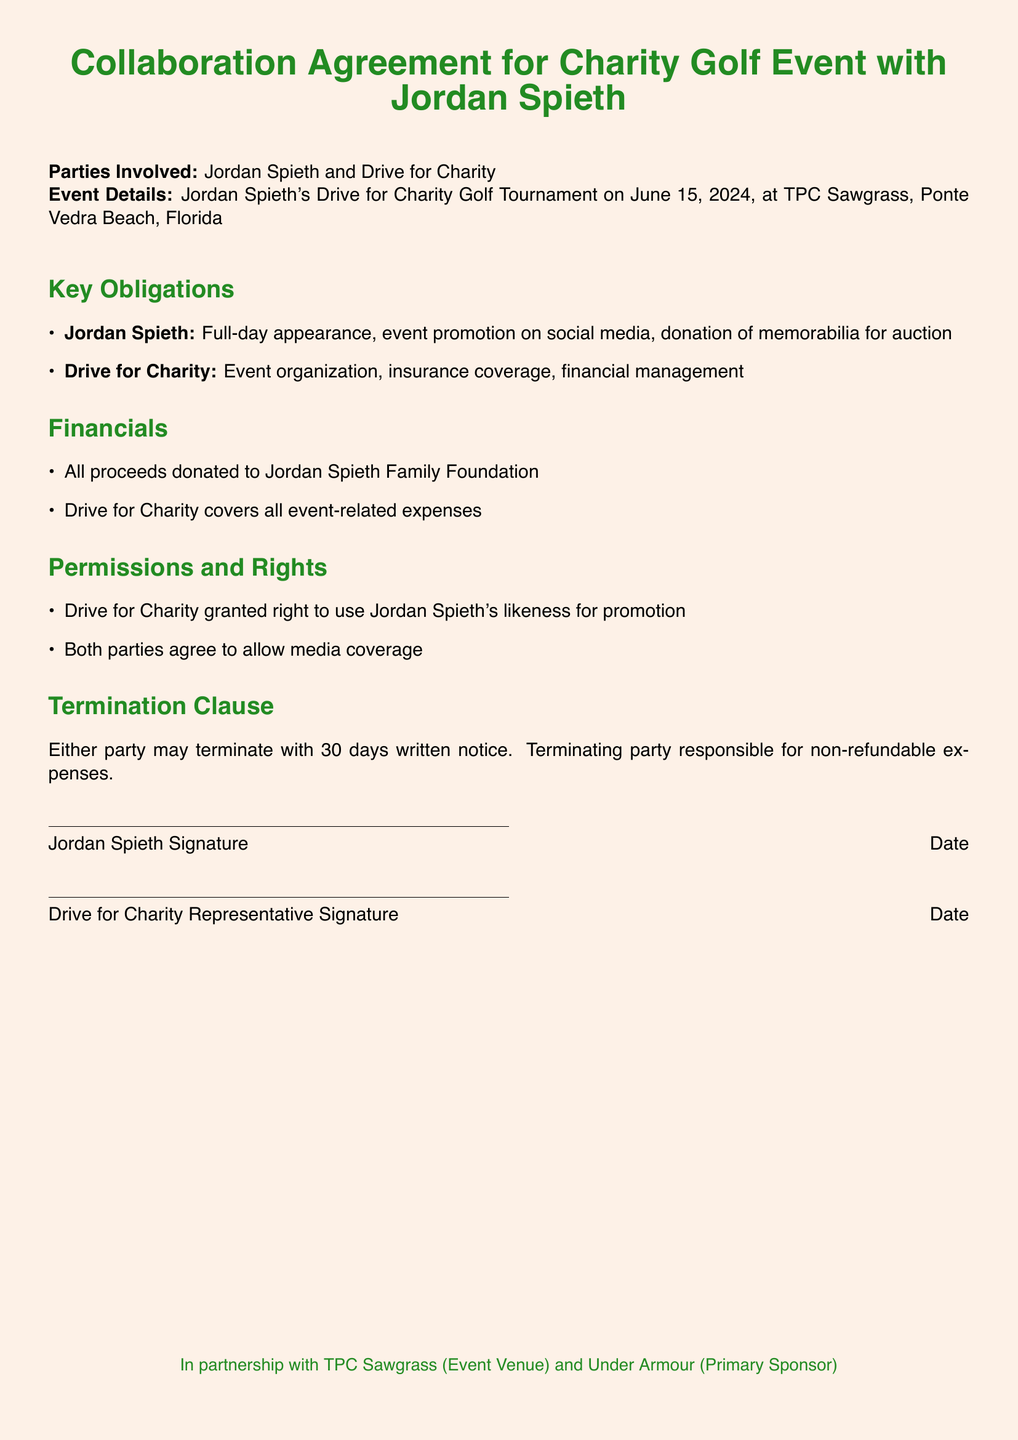What is the date of the charity golf event? The date of the charity golf event is specified in the document, which is June 15, 2024.
Answer: June 15, 2024 Who is the primary party involved in the collaboration? The primary party involved in the collaboration is Jordan Spieth, as noted in the beginning of the document.
Answer: Jordan Spieth What is the event venue for the golf tournament? The document mentions the venue where the event will be held, which is TPC Sawgrass.
Answer: TPC Sawgrass What must Jordan Spieth do as part of his obligations? One of Jordan Spieth's obligations specified in the document is a full-day appearance at the event.
Answer: Full-day appearance What happens if either party wants to terminate the agreement? The document outlines a termination clause that requires either party to provide 30 days written notice for termination.
Answer: 30 days written notice Who will receive all proceeds from the event? According to the financial section, all proceeds from the charity golf event will be donated to a specific foundation.
Answer: Jordan Spieth Family Foundation Which company is listed as the primary sponsor? The document mentions a specific company that sponsors the event, noted as Under Armour.
Answer: Under Armour What is Drive for Charity responsible for? The responsibilities assigned to Drive for Charity in the document include organizing the event and handling financial management.
Answer: Event organization, financial management 